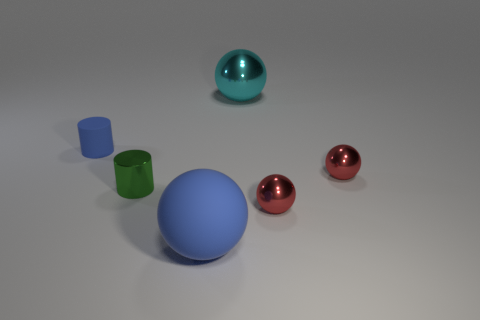Add 4 large cyan shiny spheres. How many objects exist? 10 Subtract all cylinders. How many objects are left? 4 Add 1 green metal objects. How many green metal objects exist? 2 Subtract 2 red spheres. How many objects are left? 4 Subtract all tiny objects. Subtract all small balls. How many objects are left? 0 Add 2 small green metallic cylinders. How many small green metallic cylinders are left? 3 